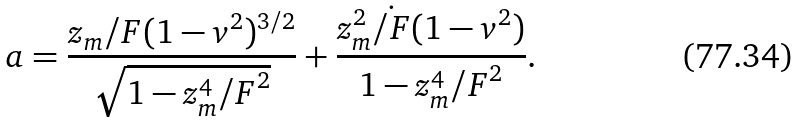<formula> <loc_0><loc_0><loc_500><loc_500>a = \frac { z _ { m } \slash { F } ( 1 - v ^ { 2 } ) ^ { 3 / 2 } } { \sqrt { 1 - z _ { m } ^ { 4 } { \slash { F } } ^ { 2 } } } + \frac { z ^ { 2 } _ { m } \dot { \slash { F } } ( 1 - v ^ { 2 } ) } { 1 - z _ { m } ^ { 4 } { \slash { F } } ^ { 2 } } .</formula> 